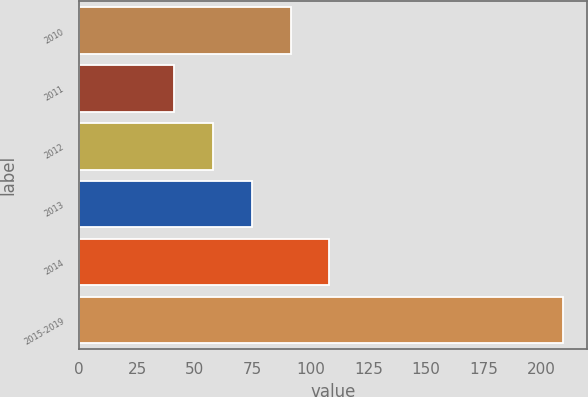Convert chart. <chart><loc_0><loc_0><loc_500><loc_500><bar_chart><fcel>2010<fcel>2011<fcel>2012<fcel>2013<fcel>2014<fcel>2015-2019<nl><fcel>91.4<fcel>41<fcel>57.8<fcel>74.6<fcel>108.2<fcel>209<nl></chart> 